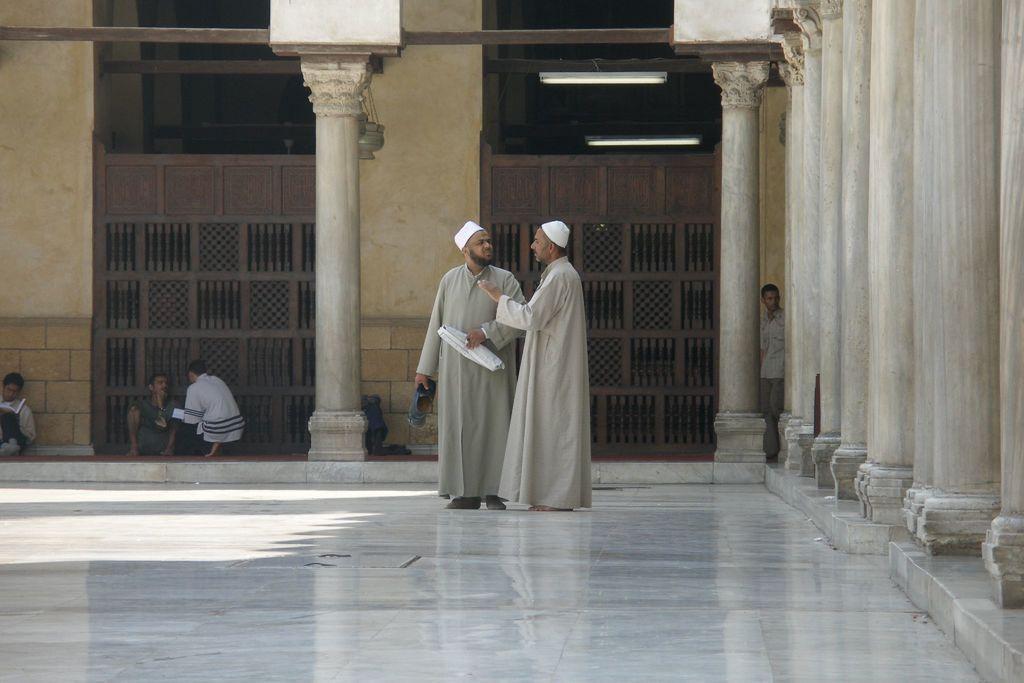Can you describe this image briefly? In this image we can see two men are standing on the floor. On the right side of the image, we can see pillars. In the background, we can see people, pillars, walls and gates. 